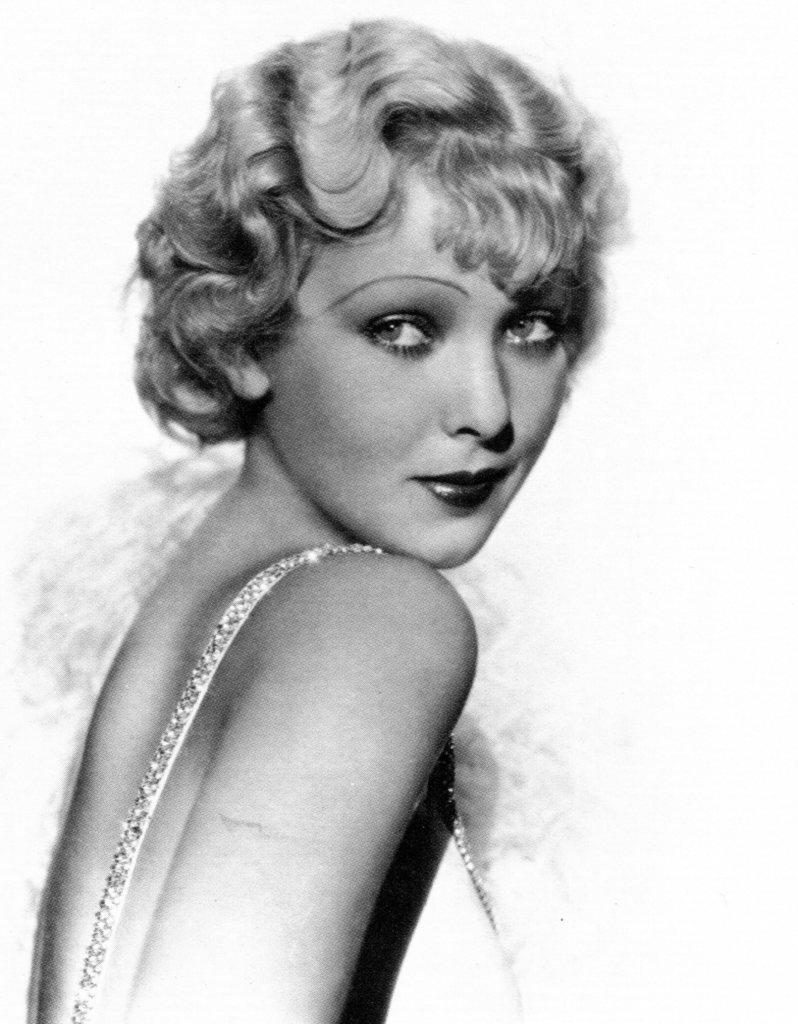How would you summarize this image in a sentence or two? It is a black and white picture of a woman. 